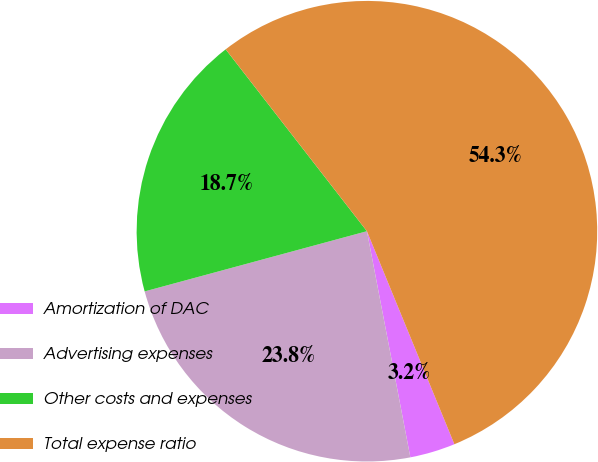Convert chart to OTSL. <chart><loc_0><loc_0><loc_500><loc_500><pie_chart><fcel>Amortization of DAC<fcel>Advertising expenses<fcel>Other costs and expenses<fcel>Total expense ratio<nl><fcel>3.18%<fcel>23.81%<fcel>18.7%<fcel>54.31%<nl></chart> 